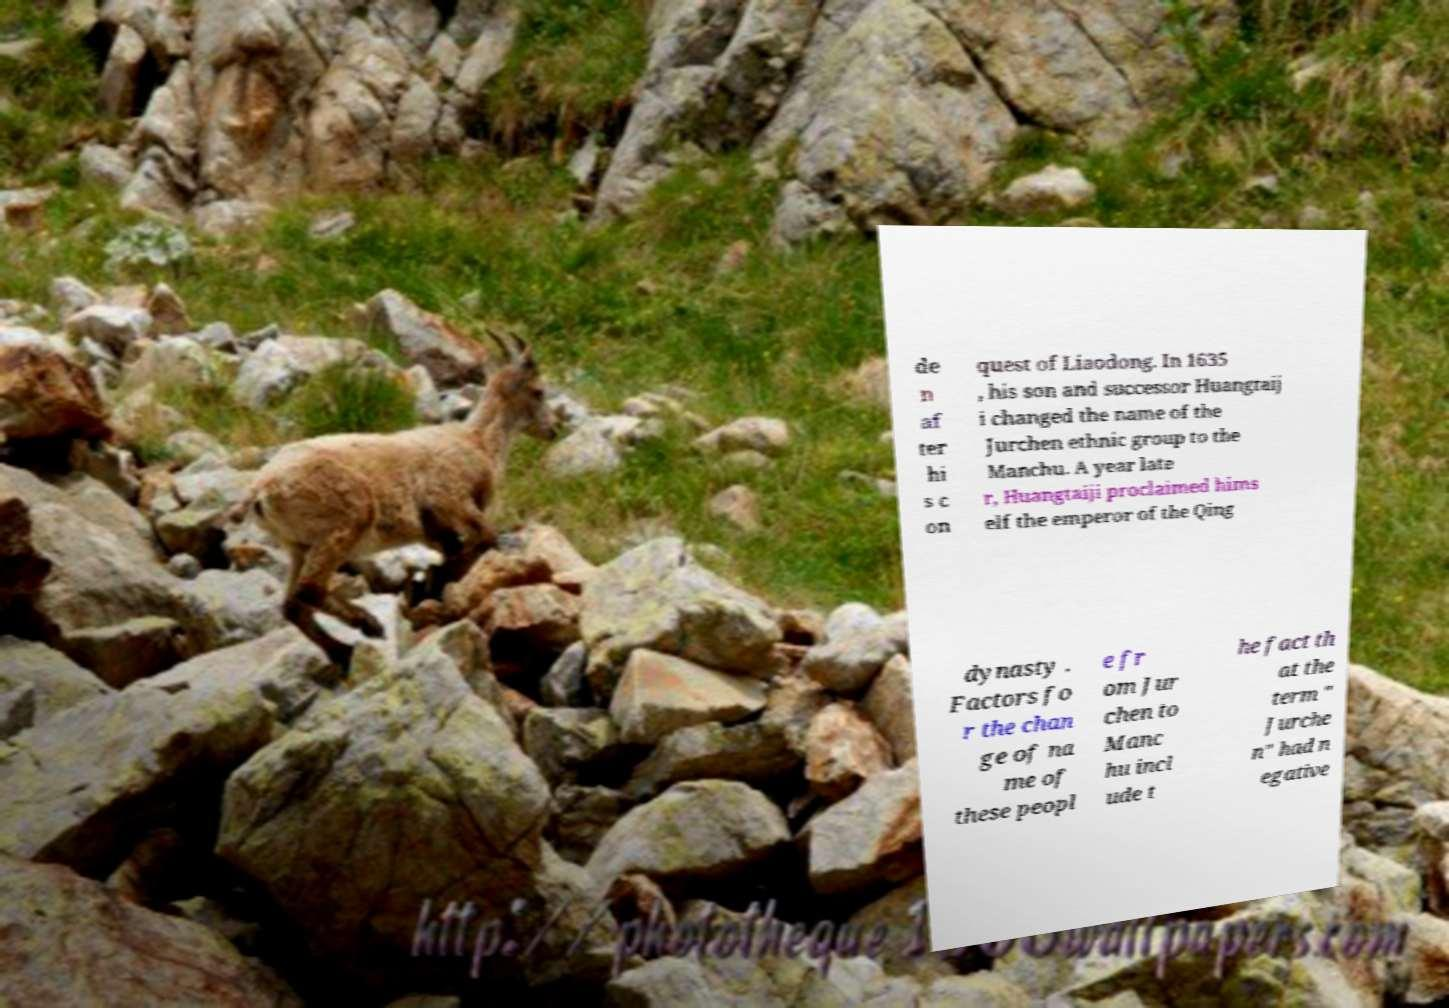What messages or text are displayed in this image? I need them in a readable, typed format. de n af ter hi s c on quest of Liaodong. In 1635 , his son and successor Huangtaij i changed the name of the Jurchen ethnic group to the Manchu. A year late r, Huangtaiji proclaimed hims elf the emperor of the Qing dynasty . Factors fo r the chan ge of na me of these peopl e fr om Jur chen to Manc hu incl ude t he fact th at the term " Jurche n" had n egative 